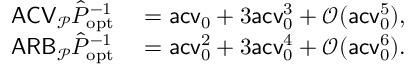Convert formula to latex. <formula><loc_0><loc_0><loc_500><loc_500>\begin{array} { r l } { A C V _ { \mathcal { P } } \hat { P } _ { o p t } ^ { - 1 } } & = a c v _ { 0 } + 3 a c v _ { 0 } ^ { 3 } + \mathcal { O } ( a c v _ { 0 } ^ { 5 } ) , } \\ { A R B _ { \mathcal { P } } \hat { P } _ { o p t } ^ { - 1 } } & = a c v _ { 0 } ^ { 2 } + 3 a c v _ { 0 } ^ { 4 } + \mathcal { O } ( a c v _ { 0 } ^ { 6 } ) . } \end{array}</formula> 